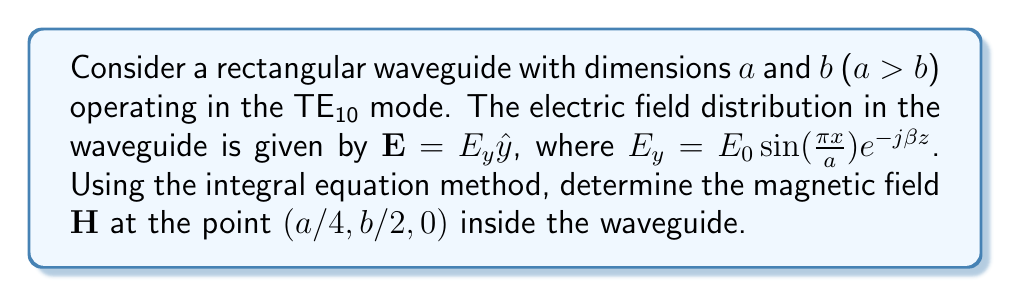Can you solve this math problem? To solve this problem, we'll follow these steps:

1) First, recall Maxwell's equations for time-harmonic fields:

   $$\nabla \times \mathbf{E} = -j\omega\mu\mathbf{H}$$

2) For the TE10 mode, we have:

   $$\mathbf{E} = E_y\hat{y} = E_0 \sin(\frac{\pi x}{a})e^{-j\beta z}\hat{y}$$

3) To find $\mathbf{H}$, we need to take the curl of $\mathbf{E}$:

   $$\nabla \times \mathbf{E} = \left(\frac{\partial E_y}{\partial z}\hat{x} - \frac{\partial E_y}{\partial x}\hat{z}\right)$$

4) Calculating the partial derivatives:

   $$\frac{\partial E_y}{\partial z} = -j\beta E_0 \sin(\frac{\pi x}{a})e^{-j\beta z}$$
   $$\frac{\partial E_y}{\partial x} = \frac{\pi}{a} E_0 \cos(\frac{\pi x}{a})e^{-j\beta z}$$

5) Substituting these into the curl equation:

   $$\nabla \times \mathbf{E} = -j\beta E_0 \sin(\frac{\pi x}{a})e^{-j\beta z}\hat{x} - \frac{\pi}{a} E_0 \cos(\frac{\pi x}{a})e^{-j\beta z}\hat{z}$$

6) Using Maxwell's equation:

   $$-j\omega\mu\mathbf{H} = -j\beta E_0 \sin(\frac{\pi x}{a})e^{-j\beta z}\hat{x} - \frac{\pi}{a} E_0 \cos(\frac{\pi x}{a})e^{-j\beta z}\hat{z}$$

7) Solving for $\mathbf{H}$:

   $$\mathbf{H} = \frac{\beta}{\omega\mu} E_0 \sin(\frac{\pi x}{a})e^{-j\beta z}\hat{x} + j\frac{\pi}{\omega\mu a} E_0 \cos(\frac{\pi x}{a})e^{-j\beta z}\hat{z}$$

8) At the point $(a/4, b/2, 0)$:

   $$\mathbf{H} = \frac{\beta}{\omega\mu} E_0 \sin(\frac{\pi}{4})\hat{x} + j\frac{\pi}{\omega\mu a} E_0 \cos(\frac{\pi}{4})\hat{z}$$

9) Simplifying:

   $$\mathbf{H} = \frac{\beta}{\omega\mu} E_0 \frac{\sqrt{2}}{2}\hat{x} + j\frac{\pi}{\omega\mu a} E_0 \frac{\sqrt{2}}{2}\hat{z}$$

This is the magnetic field at the specified point in the waveguide.
Answer: $$\mathbf{H} = \frac{\beta E_0}{\omega\mu} \frac{\sqrt{2}}{2}\hat{x} + j\frac{\pi E_0}{\omega\mu a} \frac{\sqrt{2}}{2}\hat{z}$$ 